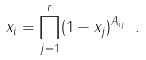<formula> <loc_0><loc_0><loc_500><loc_500>x _ { i } = \prod _ { j = 1 } ^ { r } ( 1 - x _ { j } ) ^ { A _ { i j } } \ .</formula> 